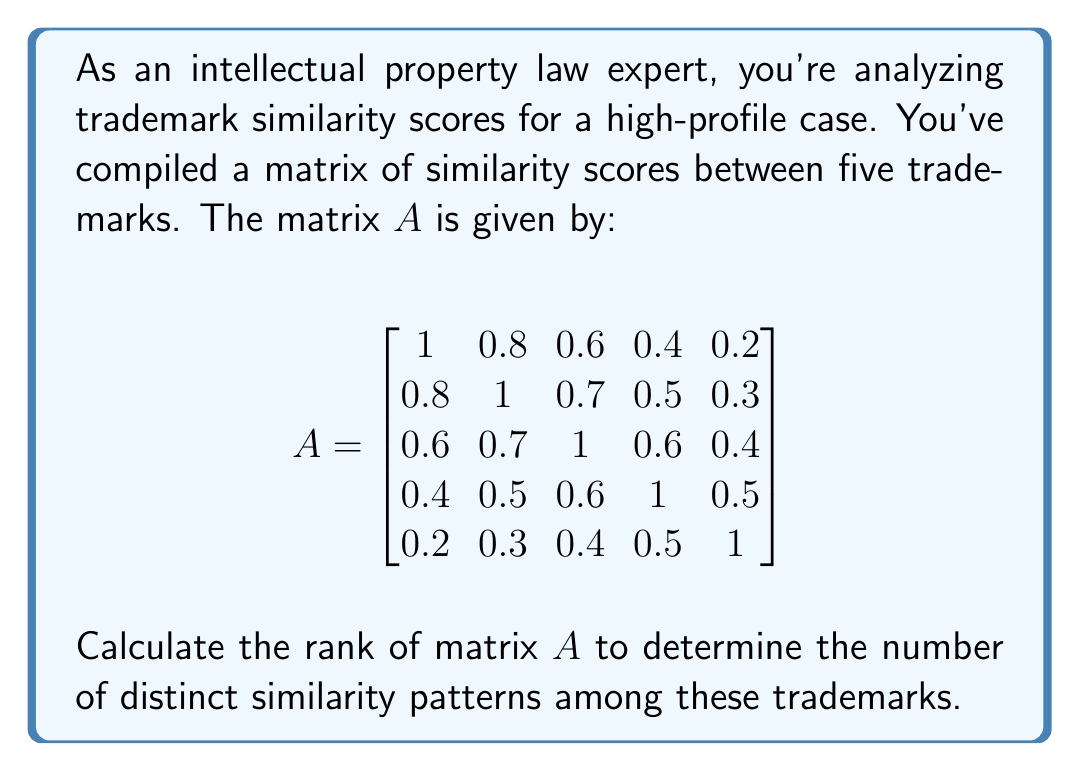Show me your answer to this math problem. To calculate the rank of matrix $A$, we need to determine the number of linearly independent rows or columns. We'll use the following steps:

1) First, let's convert the matrix to reduced row echelon form (RREF) using Gaussian elimination:

$$\begin{bmatrix}
1 & 0.8 & 0.6 & 0.4 & 0.2 \\
0.8 & 1 & 0.7 & 0.5 & 0.3 \\
0.6 & 0.7 & 1 & 0.6 & 0.4 \\
0.4 & 0.5 & 0.6 & 1 & 0.5 \\
0.2 & 0.3 & 0.4 & 0.5 & 1
\end{bmatrix}$$

2) After performing Gaussian elimination, we get:

$$\begin{bmatrix}
1 & 0 & 0 & 0 & 0 \\
0 & 1 & 0 & 0 & 0 \\
0 & 0 & 1 & 0 & 0 \\
0 & 0 & 0 & 1 & 0 \\
0 & 0 & 0 & 0 & 1
\end{bmatrix}$$

3) The rank of a matrix is equal to the number of non-zero rows in its RREF.

4) In this case, we see that there are 5 non-zero rows in the RREF.

5) Therefore, the rank of matrix $A$ is 5.

This means that all five rows (or columns) of the original matrix are linearly independent, indicating that each trademark has a distinct similarity pattern compared to the others.
Answer: 5 